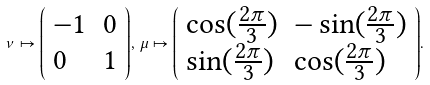<formula> <loc_0><loc_0><loc_500><loc_500>\nu \mapsto { \left ( \begin{array} { l l } { - 1 } & { 0 } \\ { 0 } & { 1 } \end{array} \right ) } , \, \mu \mapsto { \left ( \begin{array} { l l } { \cos ( { \frac { 2 \pi } { 3 } } ) } & { - \sin ( { \frac { 2 \pi } { 3 } } ) } \\ { \sin ( { \frac { 2 \pi } { 3 } } ) } & { \cos ( { \frac { 2 \pi } { 3 } } ) } \end{array} \right ) } .</formula> 